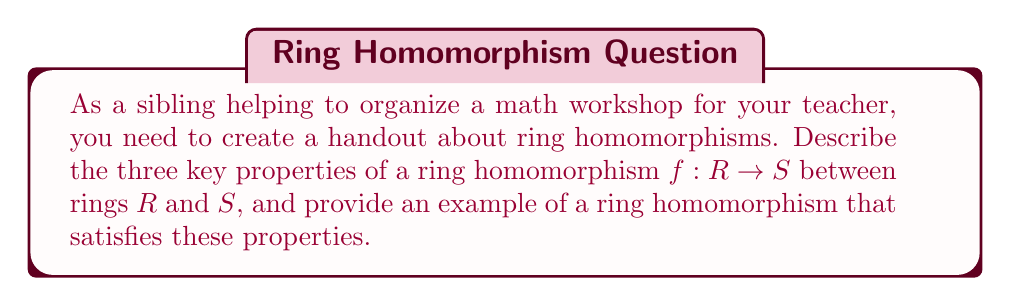Can you solve this math problem? To answer this question, we need to recall the definition of a ring homomorphism and its properties:

1. A ring homomorphism $f: R \rightarrow S$ is a function between two rings $R$ and $S$ that preserves the algebraic structure of the rings.

2. The three key properties of a ring homomorphism are:

   a) Additivity: For all $a, b \in R$, $f(a + b) = f(a) + f(b)$
   b) Multiplicativity: For all $a, b \in R$, $f(ab) = f(a)f(b)$
   c) Unity preservation: $f(1_R) = 1_S$, where $1_R$ and $1_S$ are the multiplicative identities in $R$ and $S$ respectively.

3. An example of a ring homomorphism that satisfies these properties is the natural map from the integers to the integers modulo $n$:

   Let $f: \mathbb{Z} \rightarrow \mathbb{Z}/n\mathbb{Z}$ be defined by $f(a) = [a]_n$, where $[a]_n$ represents the equivalence class of $a$ modulo $n$.

   To verify the properties:

   a) Additivity: $f(a + b) = [a + b]_n = [a]_n + [b]_n = f(a) + f(b)$
   b) Multiplicativity: $f(ab) = [ab]_n = [a]_n[b]_n = f(a)f(b)$
   c) Unity preservation: $f(1) = [1]_n$, which is the multiplicative identity in $\mathbb{Z}/n\mathbb{Z}$

   Therefore, this map satisfies all three properties of a ring homomorphism.
Answer: The three key properties of a ring homomorphism $f: R \rightarrow S$ are:

1. Additivity: $f(a + b) = f(a) + f(b)$ for all $a, b \in R$
2. Multiplicativity: $f(ab) = f(a)f(b)$ for all $a, b \in R$
3. Unity preservation: $f(1_R) = 1_S$

An example of a ring homomorphism is the natural map $f: \mathbb{Z} \rightarrow \mathbb{Z}/n\mathbb{Z}$ defined by $f(a) = [a]_n$. 